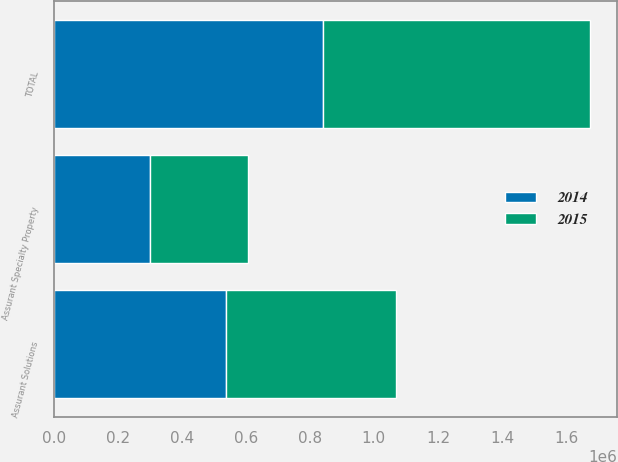<chart> <loc_0><loc_0><loc_500><loc_500><stacked_bar_chart><ecel><fcel>Assurant Solutions<fcel>Assurant Specialty Property<fcel>TOTAL<nl><fcel>2015<fcel>529093<fcel>304419<fcel>833512<nl><fcel>2014<fcel>539653<fcel>301586<fcel>841239<nl></chart> 